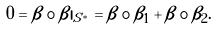Convert formula to latex. <formula><loc_0><loc_0><loc_500><loc_500>0 = \beta \circ \beta | _ { S ^ { * } } = \beta \circ \beta _ { 1 } + \beta \circ \beta _ { 2 } .</formula> 